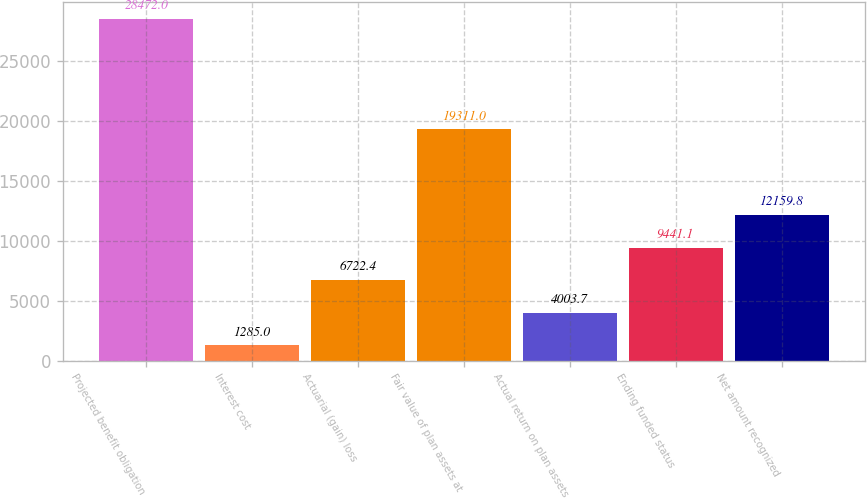<chart> <loc_0><loc_0><loc_500><loc_500><bar_chart><fcel>Projected benefit obligation<fcel>Interest cost<fcel>Actuarial (gain) loss<fcel>Fair value of plan assets at<fcel>Actual return on plan assets<fcel>Ending funded status<fcel>Net amount recognized<nl><fcel>28472<fcel>1285<fcel>6722.4<fcel>19311<fcel>4003.7<fcel>9441.1<fcel>12159.8<nl></chart> 